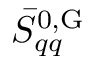Convert formula to latex. <formula><loc_0><loc_0><loc_500><loc_500>\bar { S } _ { q q } ^ { 0 , G }</formula> 